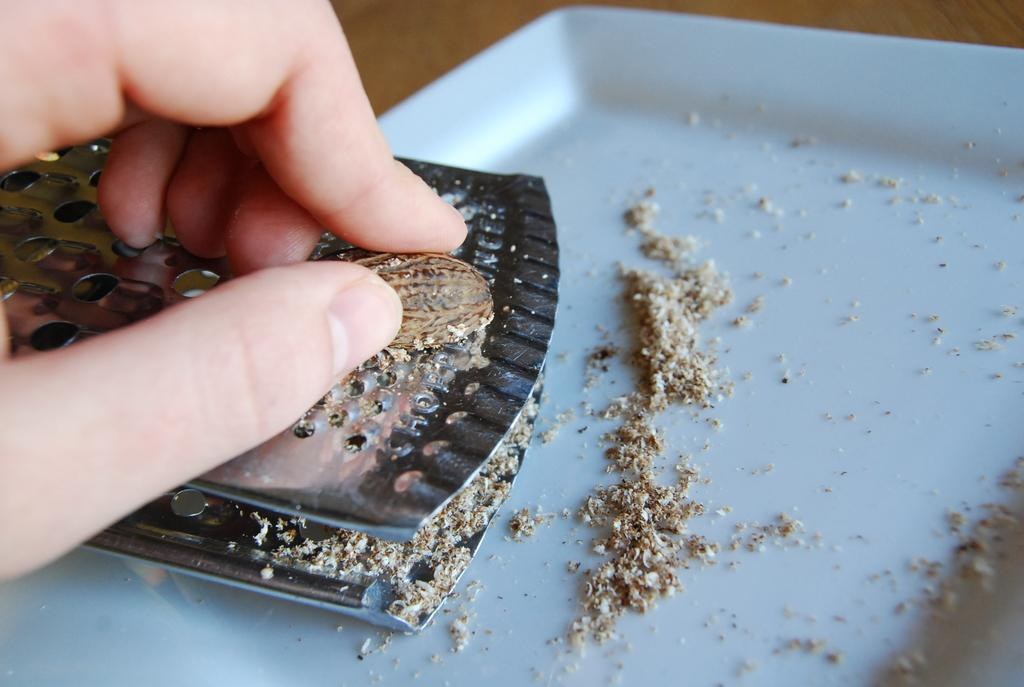Who is the main subject in the image? There is a person in the image. What is the person doing in the image? The person is grating walnut. Where is the walnut located in the image? The walnut is in the center of the image. What object is present for holding the grated walnut? There is a white-colored plate in the image. What historical event is being commemorated in the image? There is no indication of a historical event being commemorated in the image; it simply shows a person grating walnut. What relation does the person have with the walnut in the image? The person is grating the walnut, so they are likely preparing it for a dish or recipe. However, the specific relationship between the person and the walnut cannot be determined from the image alone. 